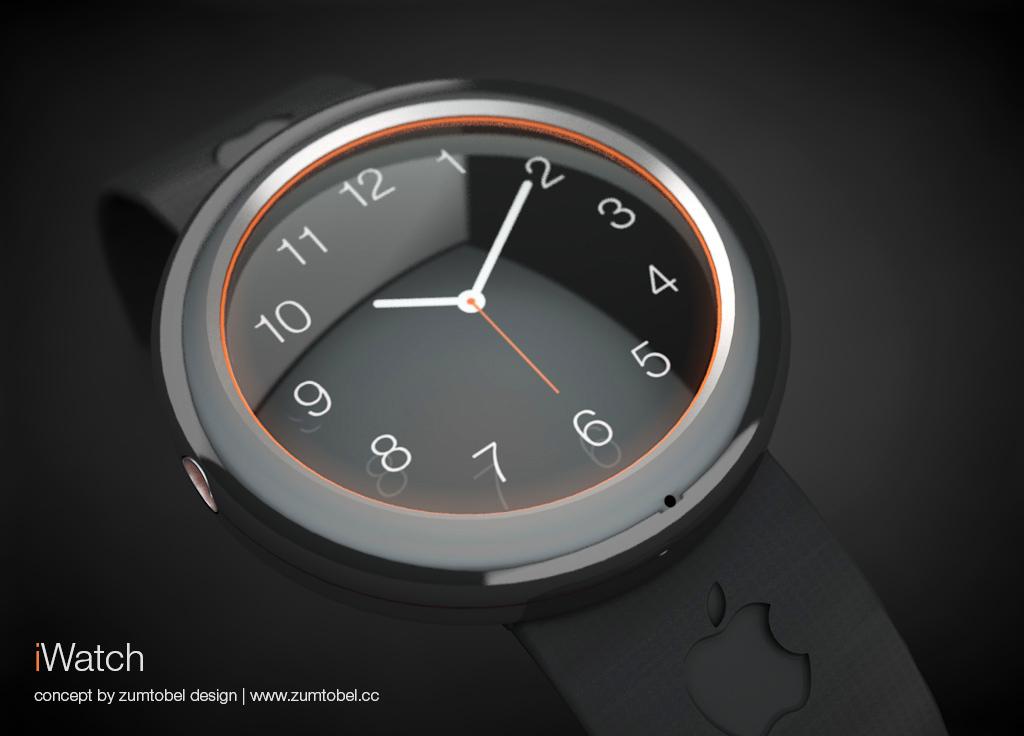What is the name of the watch?
Give a very brief answer. Iwatch. What number is at the top of the dial?
Make the answer very short. 12. 